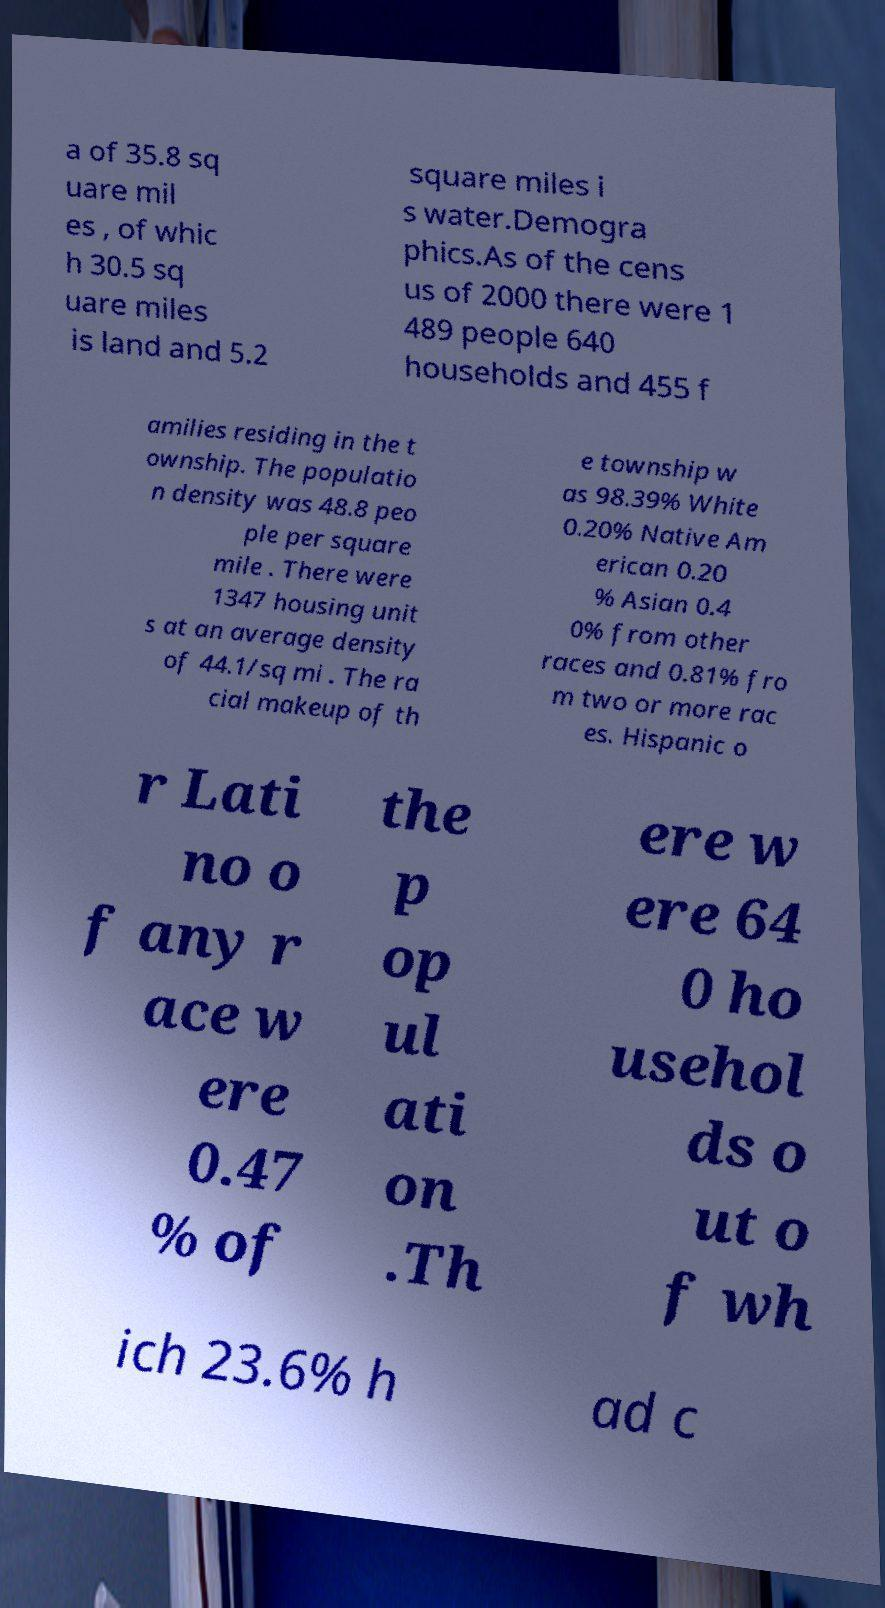Please identify and transcribe the text found in this image. a of 35.8 sq uare mil es , of whic h 30.5 sq uare miles is land and 5.2 square miles i s water.Demogra phics.As of the cens us of 2000 there were 1 489 people 640 households and 455 f amilies residing in the t ownship. The populatio n density was 48.8 peo ple per square mile . There were 1347 housing unit s at an average density of 44.1/sq mi . The ra cial makeup of th e township w as 98.39% White 0.20% Native Am erican 0.20 % Asian 0.4 0% from other races and 0.81% fro m two or more rac es. Hispanic o r Lati no o f any r ace w ere 0.47 % of the p op ul ati on .Th ere w ere 64 0 ho usehol ds o ut o f wh ich 23.6% h ad c 